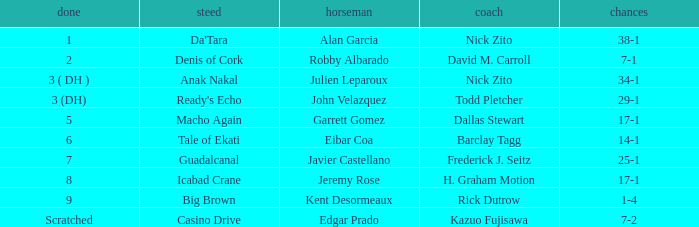Who is the Jockey for guadalcanal? Javier Castellano. 